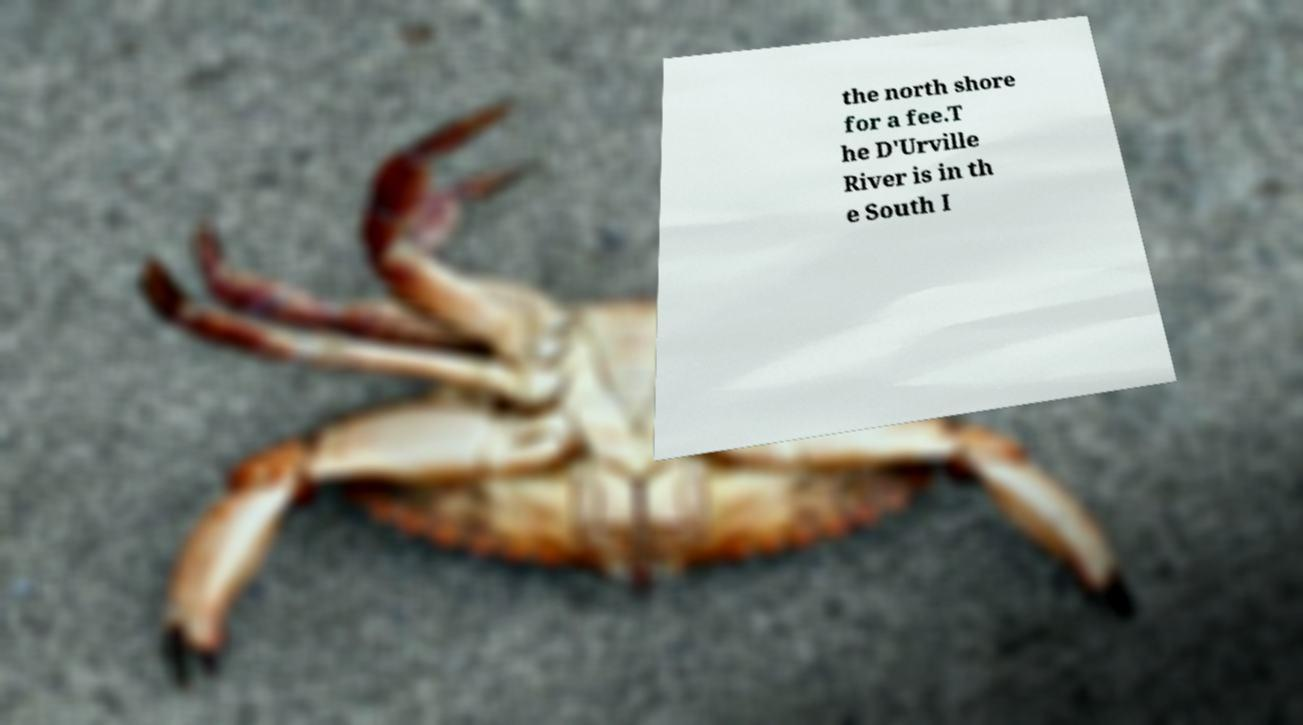Please identify and transcribe the text found in this image. the north shore for a fee.T he D'Urville River is in th e South I 